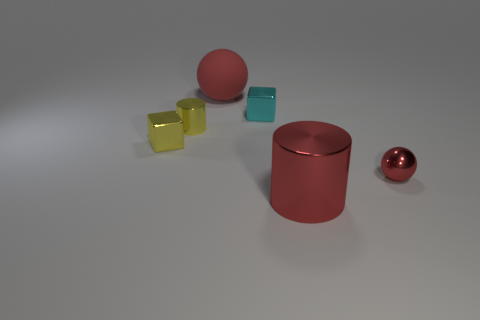Subtract all yellow cylinders. How many cylinders are left? 1 Add 2 yellow objects. How many objects exist? 8 Subtract 1 balls. How many balls are left? 1 Add 3 cubes. How many cubes exist? 5 Subtract 1 cyan cubes. How many objects are left? 5 Subtract all blocks. How many objects are left? 4 Subtract all brown blocks. Subtract all green balls. How many blocks are left? 2 Subtract all cyan spheres. How many red cylinders are left? 1 Subtract all large gray rubber objects. Subtract all tiny cyan shiny objects. How many objects are left? 5 Add 6 small metal cubes. How many small metal cubes are left? 8 